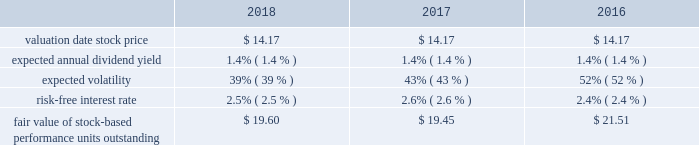Marathon oil corporation notes to consolidated financial statements stock-based performance unit awards 2013 during 2018 , 2017 and 2016 we granted 754140 , 563631 and 1205517 stock- based performance unit awards to officers .
At december 31 , 2018 , there were 1196176 units outstanding .
Total stock-based performance unit awards expense was $ 13 million in 2018 , $ 8 million in 2017 and $ 6 million in 2016 .
The key assumptions used in the monte carlo simulation to determine the fair value of stock-based performance units granted in 2018 , 2017 and 2016 were: .
18 .
Defined benefit postretirement plans and defined contribution plan we have noncontributory defined benefit pension plans covering substantially all domestic employees , as well as u.k .
Employees who were hired before april 2010 .
Certain employees located in e.g. , who are u.s .
Or u.k .
Based , also participate in these plans .
Benefits under these plans are based on plan provisions specific to each plan .
For the u.k .
Pension plan , the principal employer and plan trustees reached a decision to close the plan to future benefit accruals effective december 31 , 2015 .
We also have defined benefit plans for other postretirement benefits covering our u.s .
Employees .
Health care benefits are provided up to age 65 through comprehensive hospital , surgical and major medical benefit provisions subject to various cost- sharing features .
Post-age 65 health care benefits are provided to certain u.s .
Employees on a defined contribution basis .
Life insurance benefits are provided to certain retiree beneficiaries .
These other postretirement benefits are not funded in advance .
Employees hired after 2016 are not eligible for any postretirement health care or life insurance benefits. .
By how much did the fair value of stock-based performance units outstanding decrease from 2016 to 2018? 
Computations: ((19.60 - 21.51) / 21.51)
Answer: -0.0888. 